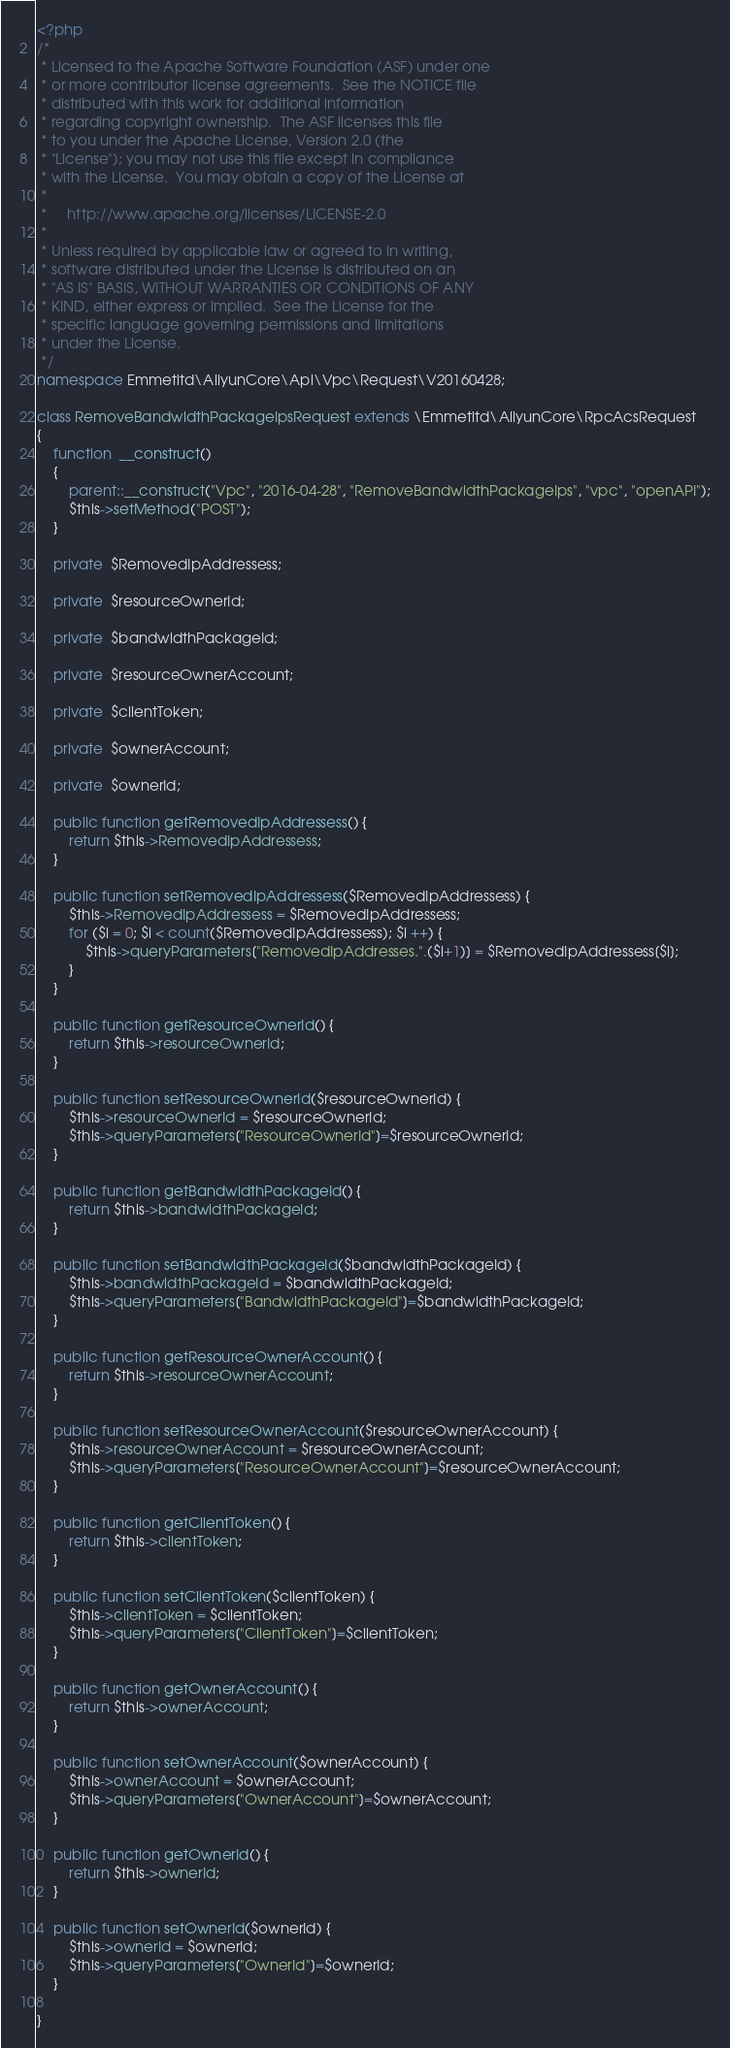Convert code to text. <code><loc_0><loc_0><loc_500><loc_500><_PHP_><?php
/*
 * Licensed to the Apache Software Foundation (ASF) under one
 * or more contributor license agreements.  See the NOTICE file
 * distributed with this work for additional information
 * regarding copyright ownership.  The ASF licenses this file
 * to you under the Apache License, Version 2.0 (the
 * "License"); you may not use this file except in compliance
 * with the License.  You may obtain a copy of the License at
 *
 *     http://www.apache.org/licenses/LICENSE-2.0
 *
 * Unless required by applicable law or agreed to in writing,
 * software distributed under the License is distributed on an
 * "AS IS" BASIS, WITHOUT WARRANTIES OR CONDITIONS OF ANY
 * KIND, either express or implied.  See the License for the
 * specific language governing permissions and limitations
 * under the License.
 */
namespace Emmetltd\AliyunCore\Api\Vpc\Request\V20160428;

class RemoveBandwidthPackageIpsRequest extends \Emmetltd\AliyunCore\RpcAcsRequest
{
	function  __construct()
	{
		parent::__construct("Vpc", "2016-04-28", "RemoveBandwidthPackageIps", "vpc", "openAPI");
		$this->setMethod("POST");
	}

	private  $RemovedIpAddressess;

	private  $resourceOwnerId;

	private  $bandwidthPackageId;

	private  $resourceOwnerAccount;

	private  $clientToken;

	private  $ownerAccount;

	private  $ownerId;

	public function getRemovedIpAddressess() {
		return $this->RemovedIpAddressess;
	}

	public function setRemovedIpAddressess($RemovedIpAddressess) {
		$this->RemovedIpAddressess = $RemovedIpAddressess;
		for ($i = 0; $i < count($RemovedIpAddressess); $i ++) {	
			$this->queryParameters["RemovedIpAddresses.".($i+1)] = $RemovedIpAddressess[$i];
		}
	}

	public function getResourceOwnerId() {
		return $this->resourceOwnerId;
	}

	public function setResourceOwnerId($resourceOwnerId) {
		$this->resourceOwnerId = $resourceOwnerId;
		$this->queryParameters["ResourceOwnerId"]=$resourceOwnerId;
	}

	public function getBandwidthPackageId() {
		return $this->bandwidthPackageId;
	}

	public function setBandwidthPackageId($bandwidthPackageId) {
		$this->bandwidthPackageId = $bandwidthPackageId;
		$this->queryParameters["BandwidthPackageId"]=$bandwidthPackageId;
	}

	public function getResourceOwnerAccount() {
		return $this->resourceOwnerAccount;
	}

	public function setResourceOwnerAccount($resourceOwnerAccount) {
		$this->resourceOwnerAccount = $resourceOwnerAccount;
		$this->queryParameters["ResourceOwnerAccount"]=$resourceOwnerAccount;
	}

	public function getClientToken() {
		return $this->clientToken;
	}

	public function setClientToken($clientToken) {
		$this->clientToken = $clientToken;
		$this->queryParameters["ClientToken"]=$clientToken;
	}

	public function getOwnerAccount() {
		return $this->ownerAccount;
	}

	public function setOwnerAccount($ownerAccount) {
		$this->ownerAccount = $ownerAccount;
		$this->queryParameters["OwnerAccount"]=$ownerAccount;
	}

	public function getOwnerId() {
		return $this->ownerId;
	}

	public function setOwnerId($ownerId) {
		$this->ownerId = $ownerId;
		$this->queryParameters["OwnerId"]=$ownerId;
	}
	
}</code> 